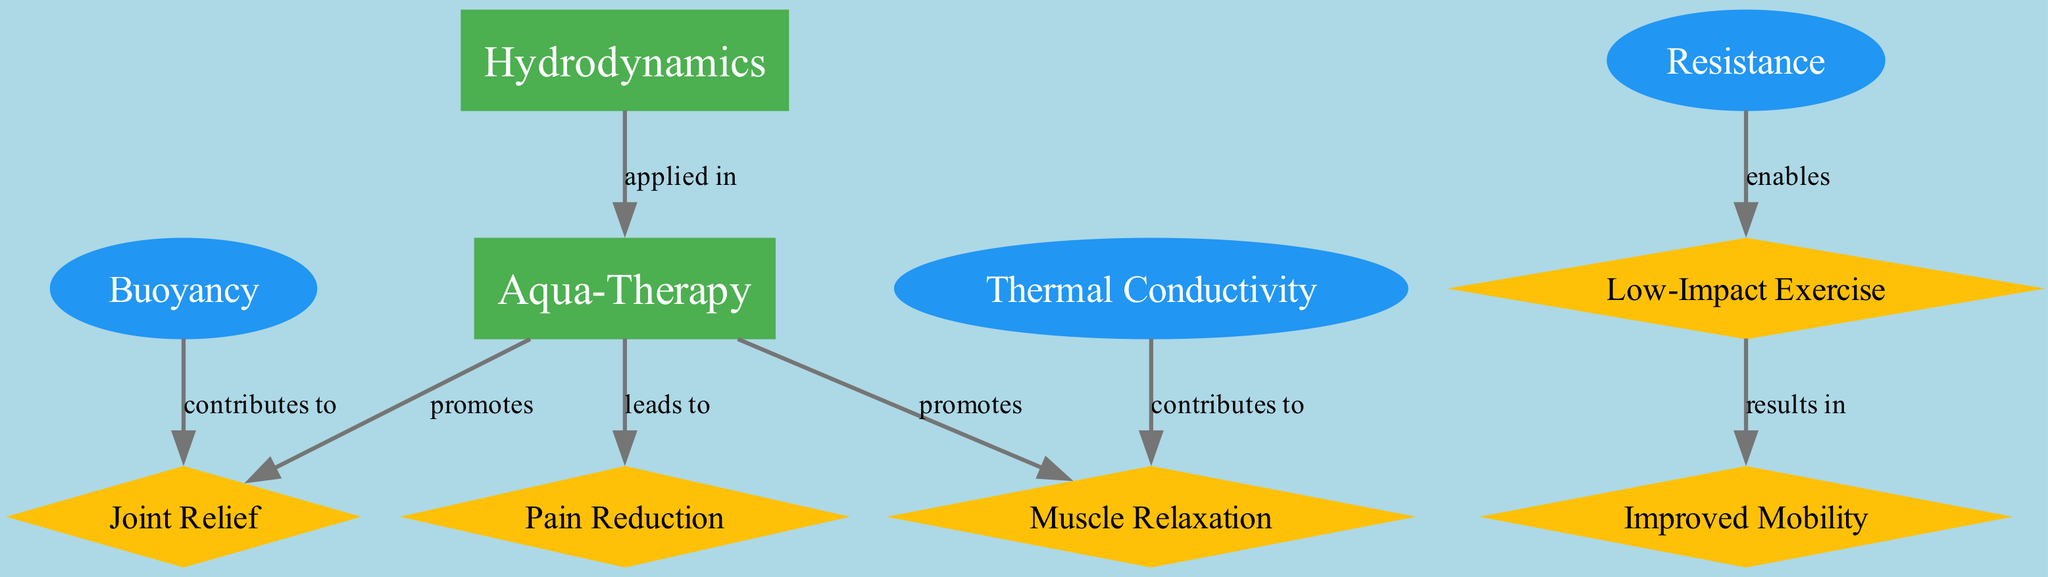What are the two main concepts in this diagram? The two main concepts are Hydrodynamics and Aqua-Therapy, represented as boxes in the diagram.
Answer: Hydrodynamics, Aqua-Therapy How many benefits are listed in the diagram? There are four benefits listed: Joint Relief, Muscle Relaxation, Pain Reduction, and Improved Mobility. These are represented as diamond shapes.
Answer: 4 What does Aqua-Therapy promote related to muscle function? Aqua-Therapy promotes Muscle Relaxation, which is shown as a direct link in the diagram.
Answer: Muscle Relaxation Which factor contributes to Joint Relief? Buoyancy contributes to Joint Relief, indicated by the relationship between these two nodes in the diagram.
Answer: Buoyancy What relationship exists between Resistance and Low-Impact Exercise? The relationship is that Resistance enables Low-Impact Exercise; this is showcased as an edge showing the enabling connection.
Answer: enables How does Thermal Conductivity influence muscle function? Thermal Conductivity contributes to Muscle Relaxation; this connection shows how temperature affects muscle behavior in this context.
Answer: contributes to What results from Low-Impact Exercise according to the diagram? Improved Mobility results from Low-Impact Exercise, indicating a positive outcome of engaging in such activities.
Answer: Improved Mobility Which connection indicates a direct benefit of Aqua-Therapy for pain? Aqua-Therapy leads to Pain Reduction, representing a beneficial outcome of engaging in therapy.
Answer: leads to How is the relationship represented between Hydrodynamics and Aqua-Therapy? The relationship is represented by the edge labeled "applied in", showing that Hydrodynamics is a concept applied in Aqua-Therapy.
Answer: applied in 